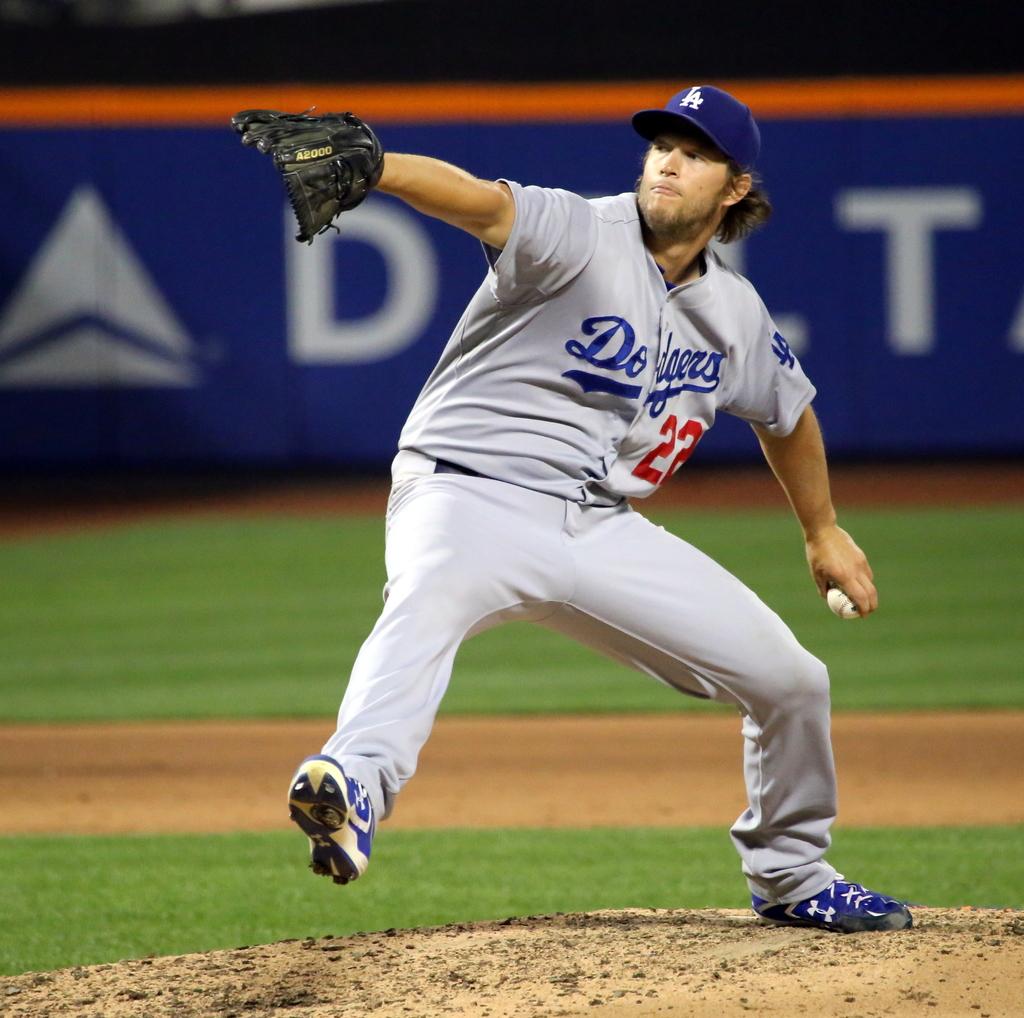What letter is in the background under the pitcher's glove?
Your answer should be very brief. D. 